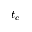Convert formula to latex. <formula><loc_0><loc_0><loc_500><loc_500>t _ { c }</formula> 